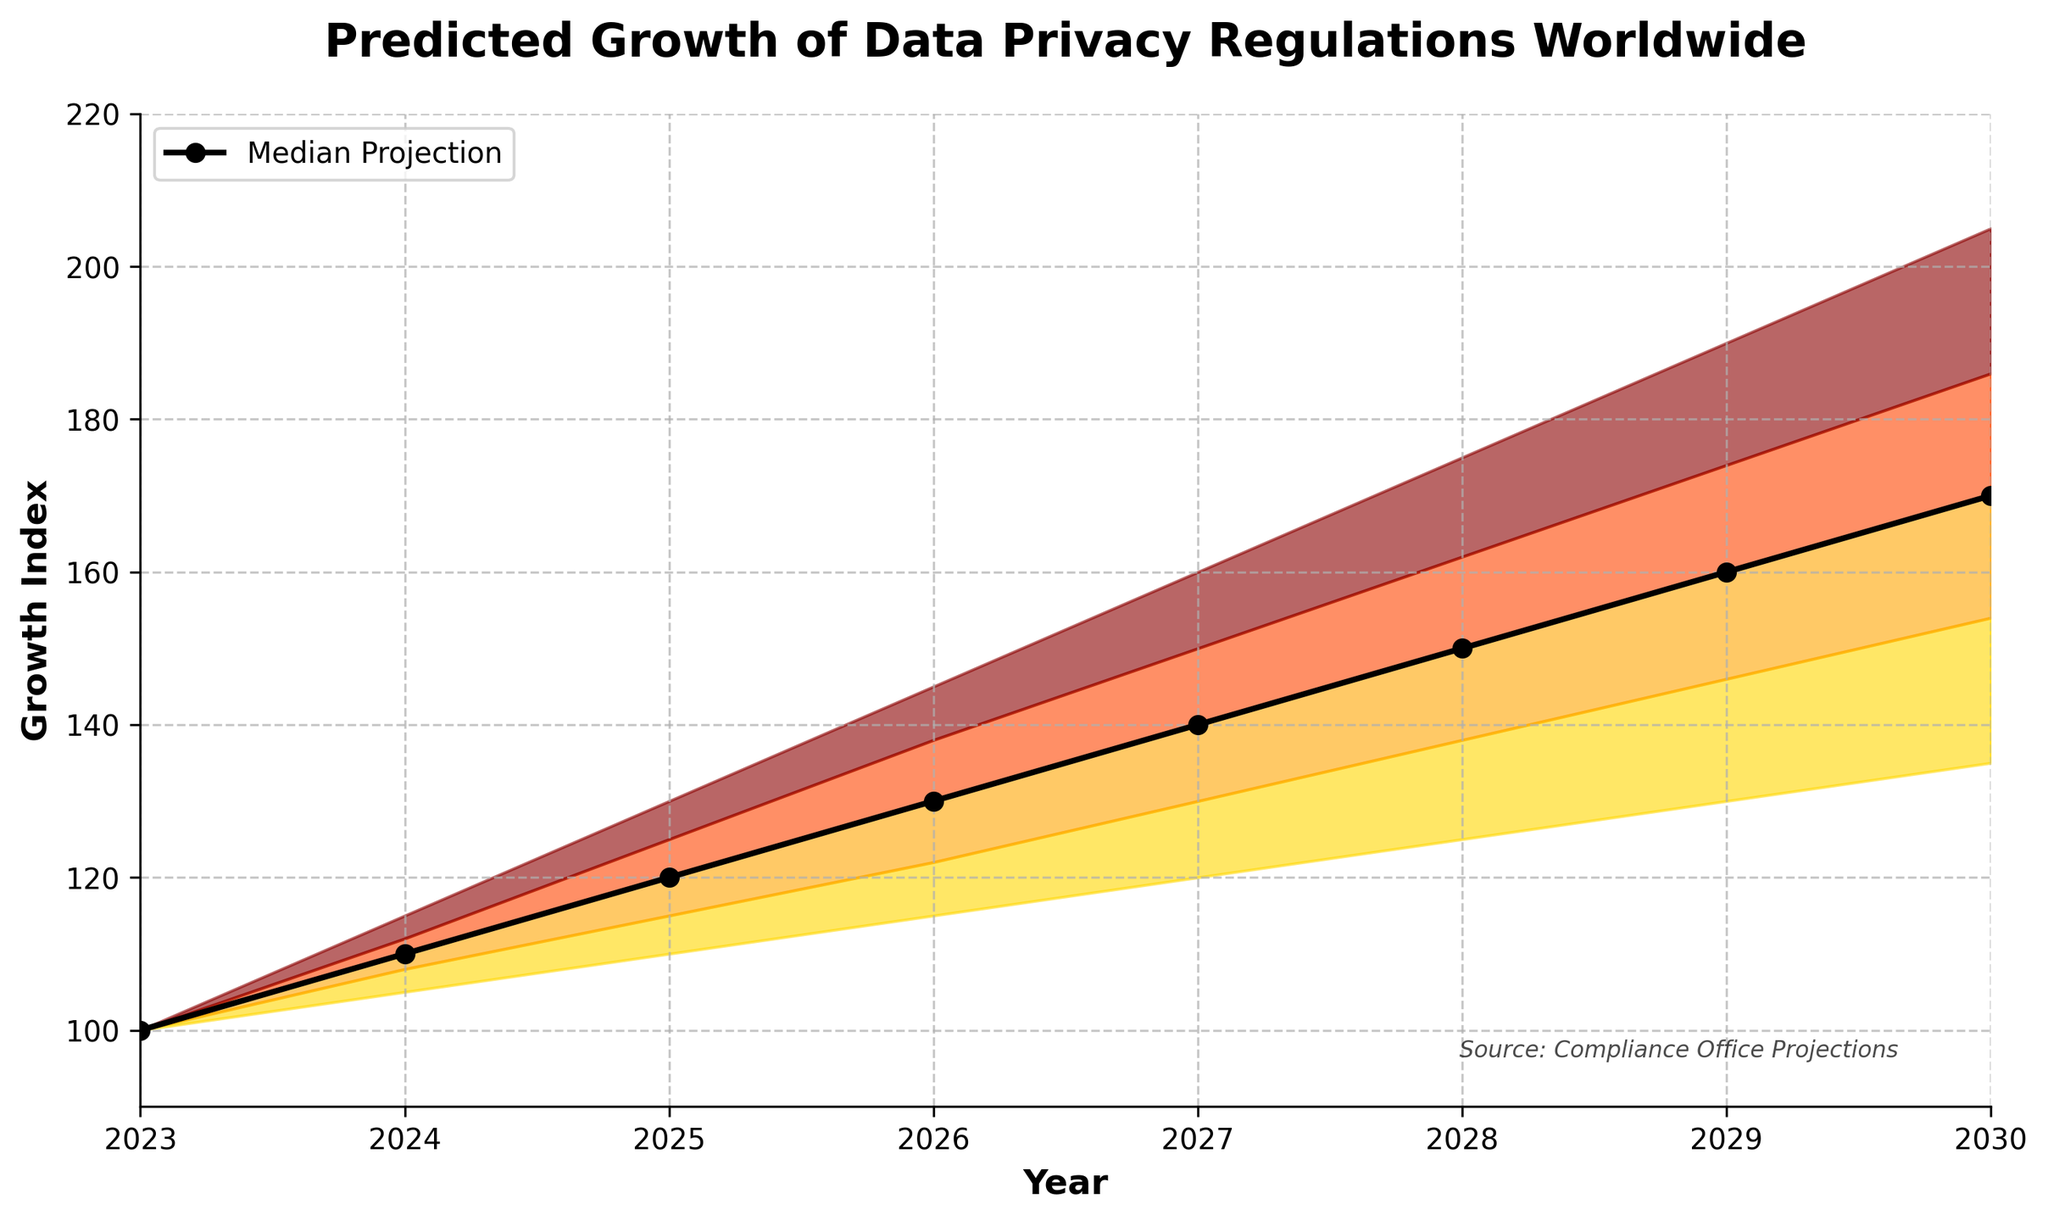What is the title of the figure? The title is clearly displayed at the top of the figure as "Predicted Growth of Data Privacy Regulations Worldwide".
Answer: Predicted Growth of Data Privacy Regulations Worldwide What is the value range for the "Mid" projection in 2027? To find the range, check the "Mid" value for the year 2027, which is 140, and compare it to its lower and upper bounds, "Low-Mid" and "Mid-High". In 2027, the "Low-Mid" value is 130, and the "Mid-High" value is 150. So the range is between 130 and 150.
Answer: 130 to 150 How much does the "High" prediction for 2029 differ from the "Low" prediction for the same year? Look at the "High" and "Low" values for the year 2029. The "High" value is 190, and the "Low" value is 130. The difference is calculated by subtracting 130 from 190.
Answer: 60 Which year shows the steepest predicted increase in the "Mid" projection from the previous year? To determine this, calculate the differences in the "Mid" values between consecutive years and identify the largest increase. The differences are: 2024: 10-0=10, 2025: 120-110=10, 2026: 130-120=10, 2027: 140-130=10, 2028: 150-140=10, 2029: 160-150=10, and 2030: 170-160=10. All annual increases are equal at 10 units.
Answer: 2024 (all differences are equal) What is the median value of the predictions for 2025? The predictions for 2025 are: 110, 115, 120, 125, and 130. To find the median, sort these values and pick the middle one, which is already sorted.
Answer: 120 By how much does the "Low" projection for 2030 exceed the "Low" projection for 2023? For 2030, the "Low" value is 135, and for 2023, it is 100. Subtract 100 from 135 to get the increase.
Answer: 35 Are the projections from 2023 to 2024 consistent in each prediction band? To determine consistency, observe if the growth from 2023 to 2024 is positive across all bands. From the data: "Low" increases from 100 to 105, "Low-Mid" from 100 to 108, "Mid" from 100 to 110, "Mid-High" from 100 to 112, and "High" from 100 to 115. Each band shows a positive increase.
Answer: Yes Which projection category has the highest value in 2030, and what is it? To identify this, check the value in each prediction category for 2030. The highest value belongs to the "High" category, which is 205.
Answer: High, 205 What color represents the area between the "Low-Mid" and "Mid" projections? The colors of the bands are derived from a custom colormap, where the area between "Low-Mid" and "Mid" is a gradient color between the second and third shades. This typically appears as a shade between orange and red.
Answer: A shade between orange and red How does the median value change between 2028 and 2029? Locate the "Mid" values for 2028 and 2029 to calculate the change. For 2028, it is 150, and for 2029, it is 160. The change is 160 - 150, which is an increase of 10.
Answer: Increases by 10 